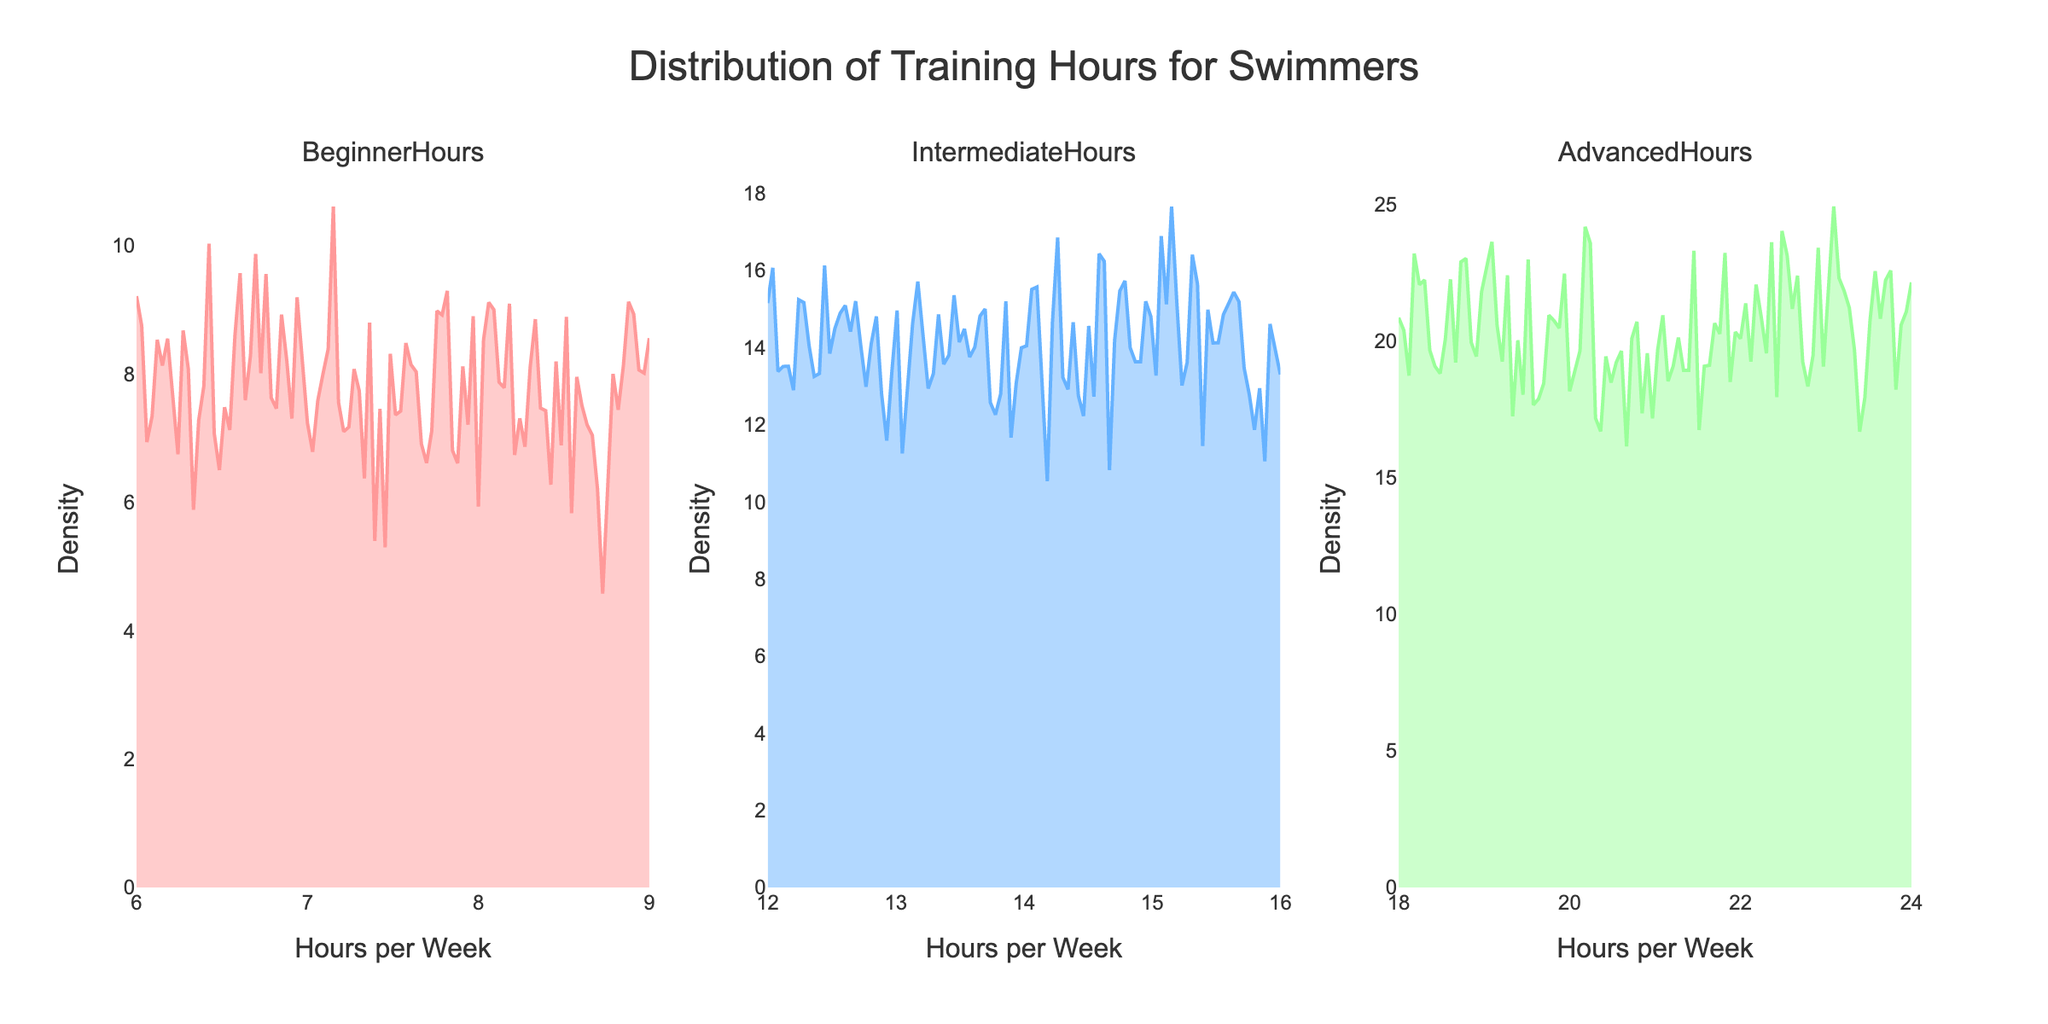What is the title of the figure? The title of the figure is prominently displayed at the top.
Answer: "Distribution of Training Hours for Swimmers" How many subplots are there in the figure? The figure is divided into multiple sections, and each section is a subplot.
Answer: 3 What are the categories shown in each subplot? Each subplot has a title that indicates a specific category.
Answer: BeginnerHours, IntermediateHours, AdvancedHours What do the x-axes in the subplots represent? The x-axes at the bottom of each subplot are labeled to indicate what they measure.
Answer: Hours per Week What does the y-axis represent in these subplots? The y-axis is labeled to show what is being measured vertically across all subplots.
Answer: Density What color is used for the `BeginnerHours` subplot? The `BeginnerHours` subplot uses a specific color for its density plot line.
Answer: Pink Which category shows the highest density at any point? Identify the subplot with the tallest peak in the density plot.
Answer: AdvancedHours Between `BeginnerHours` and `IntermediateHours`, which category has a wider spread of training hours? Compare the width of the distributions in each subplot.
Answer: IntermediateHours What is the approximate range of training hours for the `AdvancedHours` category? Look at the x-axis range that is covered by the density plot for `AdvancedHours`.
Answer: 18-24 hours Which category's density plot indicates the most consistent training hours among swimmers? Consistency can be inferred from a narrow peak in the density plot.
Answer: BeginnerHours 